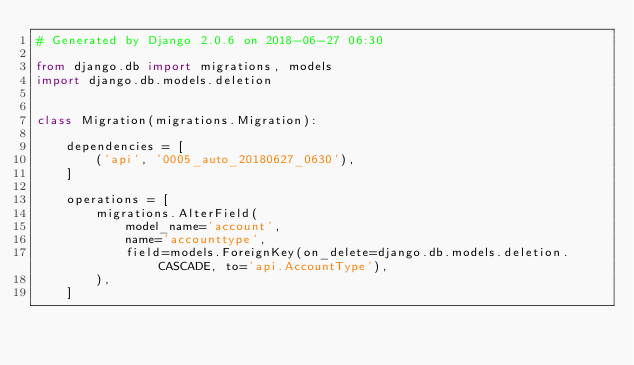Convert code to text. <code><loc_0><loc_0><loc_500><loc_500><_Python_># Generated by Django 2.0.6 on 2018-06-27 06:30

from django.db import migrations, models
import django.db.models.deletion


class Migration(migrations.Migration):

    dependencies = [
        ('api', '0005_auto_20180627_0630'),
    ]

    operations = [
        migrations.AlterField(
            model_name='account',
            name='accounttype',
            field=models.ForeignKey(on_delete=django.db.models.deletion.CASCADE, to='api.AccountType'),
        ),
    ]
</code> 